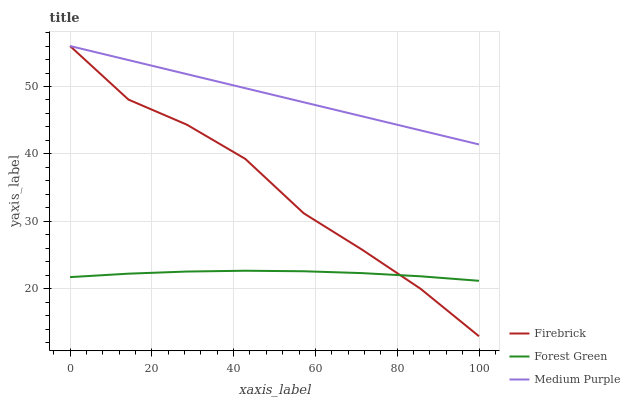Does Firebrick have the minimum area under the curve?
Answer yes or no. No. Does Firebrick have the maximum area under the curve?
Answer yes or no. No. Is Forest Green the smoothest?
Answer yes or no. No. Is Forest Green the roughest?
Answer yes or no. No. Does Forest Green have the lowest value?
Answer yes or no. No. Does Forest Green have the highest value?
Answer yes or no. No. Is Forest Green less than Medium Purple?
Answer yes or no. Yes. Is Medium Purple greater than Forest Green?
Answer yes or no. Yes. Does Forest Green intersect Medium Purple?
Answer yes or no. No. 